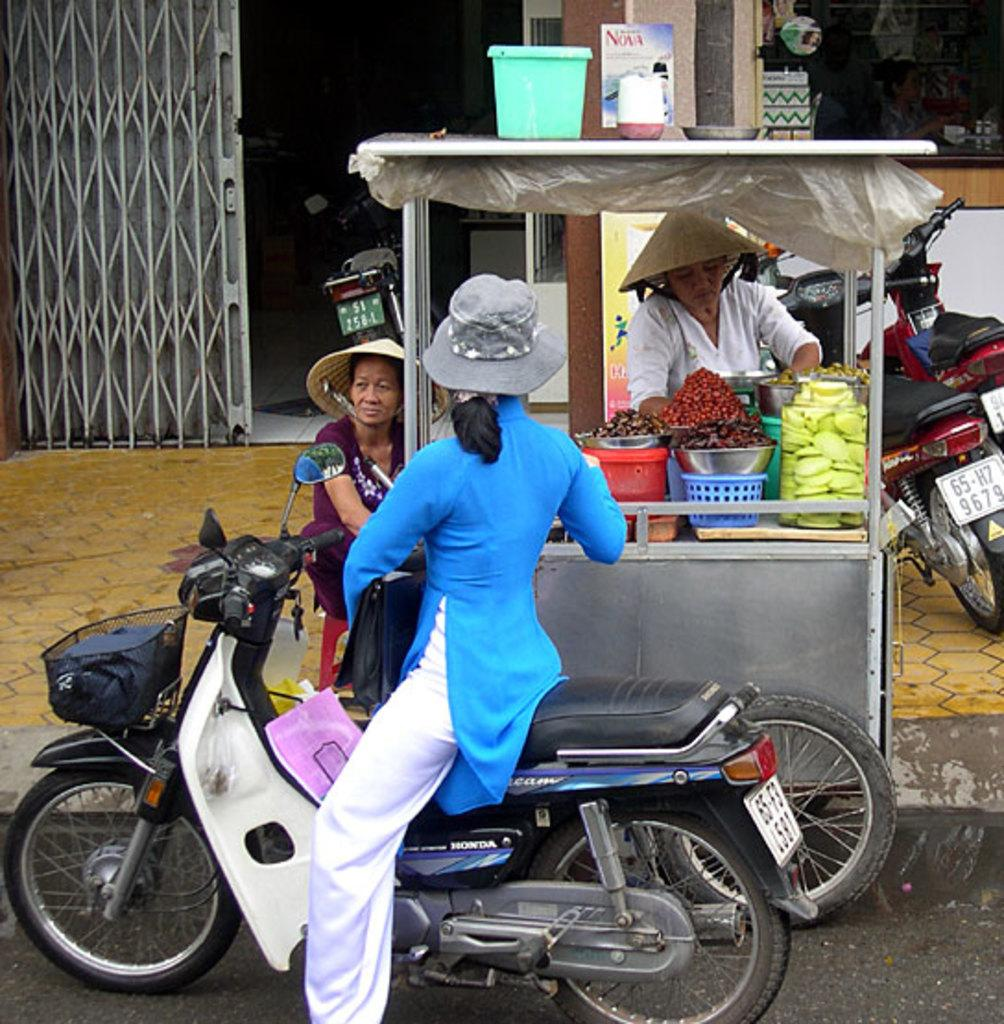What is the woman in the image doing? The woman is on a bike. What can be seen in the background of the image? There is a store with food materials, baskets, two women, a metal door, and vehicles in the background. How many owls are sitting on the metal door in the image? There are no owls present in the image. What type of metal is the boy using to build a robot in the image? There is no boy or robot present in the image. 